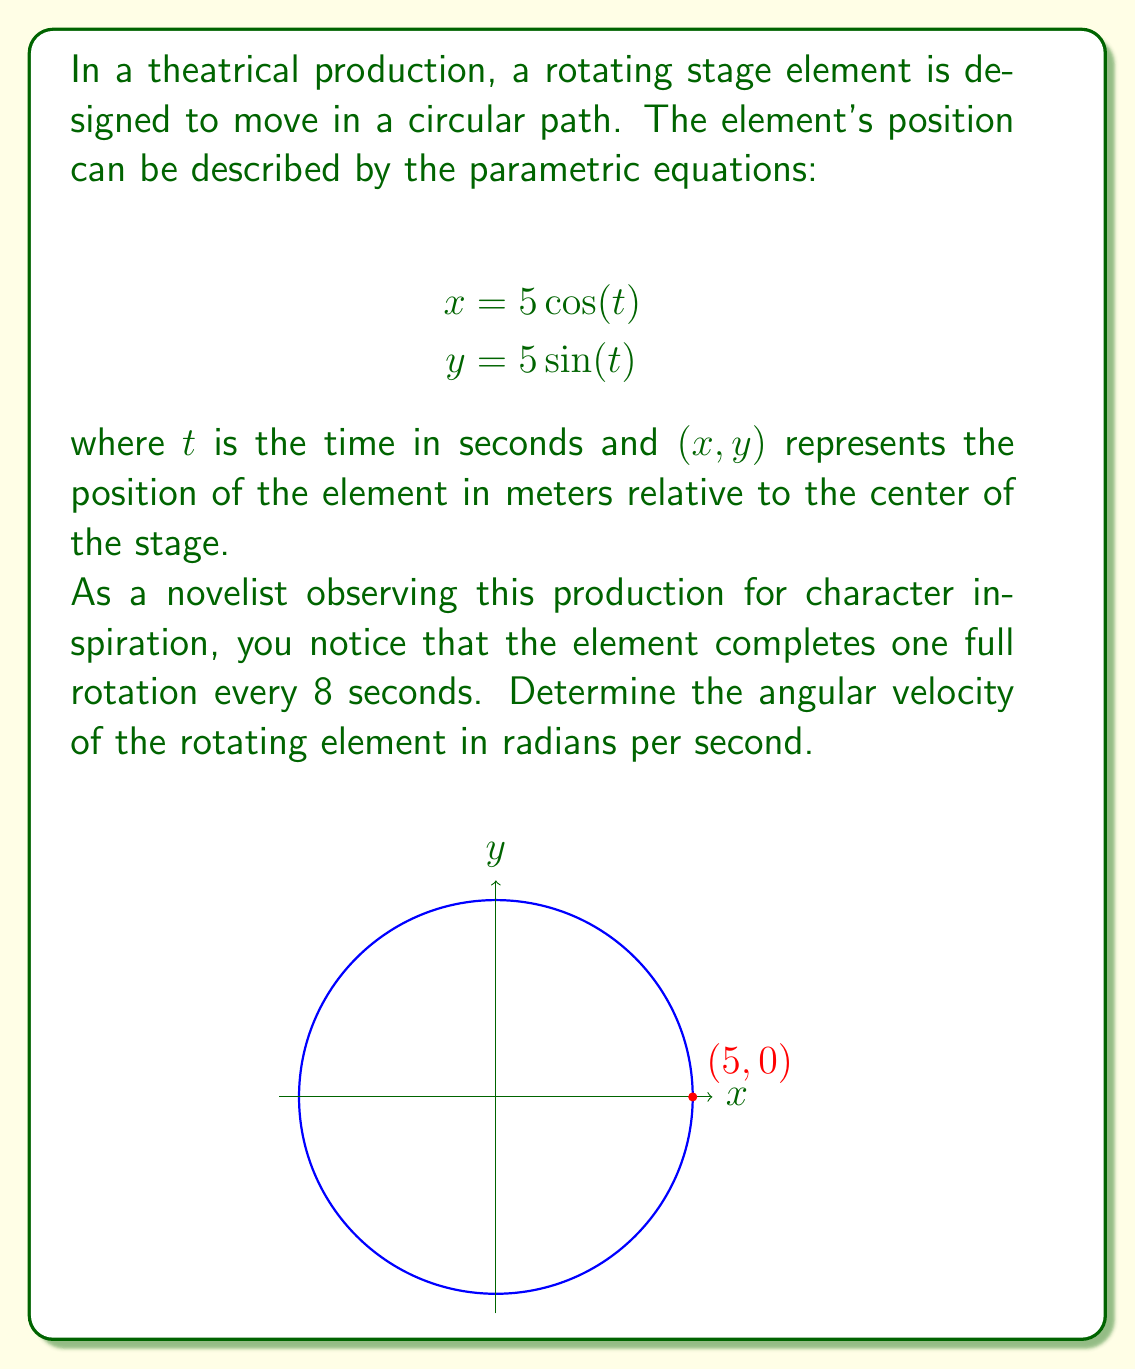Solve this math problem. Let's approach this step-by-step:

1) In parametric equations, $t$ is often used to represent time. Here, $t$ is given in seconds.

2) We know that one full rotation takes 8 seconds. In circular motion, one full rotation corresponds to $2\pi$ radians.

3) We can set up the relationship:
   $$2\pi \text{ radians} = 8 \text{ seconds}$$

4) To find the angular velocity $\omega$ (in radians per second), we divide the total angle by the total time:

   $$\omega = \frac{2\pi \text{ radians}}{8 \text{ seconds}}$$

5) Simplify:
   $$\omega = \frac{\pi}{4} \text{ radians/second}$$

6) This result tells us that the stage element rotates $\frac{\pi}{4}$ radians every second.

7) We can verify this by substituting into our original equations:
   After 8 seconds ($t=8$), we have:
   $$x = 5\cos(8 \cdot \frac{\pi}{4}) = 5\cos(2\pi) = 5$$
   $$y = 5\sin(8 \cdot \frac{\pi}{4}) = 5\sin(2\pi) = 0$$
   
   This confirms that the element has completed one full rotation, returning to its starting point (5,0).
Answer: $\frac{\pi}{4}$ radians/second 